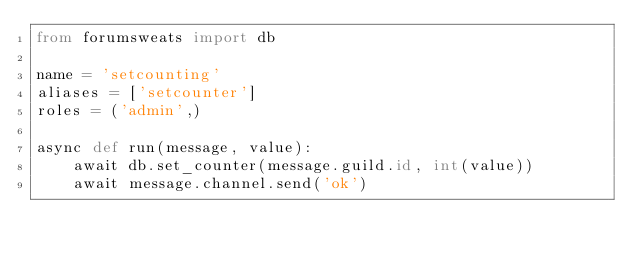<code> <loc_0><loc_0><loc_500><loc_500><_Python_>from forumsweats import db

name = 'setcounting'
aliases = ['setcounter']
roles = ('admin',)

async def run(message, value):
	await db.set_counter(message.guild.id, int(value))
	await message.channel.send('ok')
</code> 